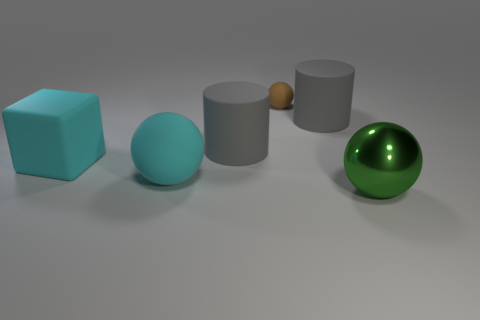Add 2 large things. How many objects exist? 8 Subtract all blocks. How many objects are left? 5 Add 4 brown objects. How many brown objects are left? 5 Add 4 gray rubber things. How many gray rubber things exist? 6 Subtract 0 green cylinders. How many objects are left? 6 Subtract all cyan objects. Subtract all tiny brown matte objects. How many objects are left? 3 